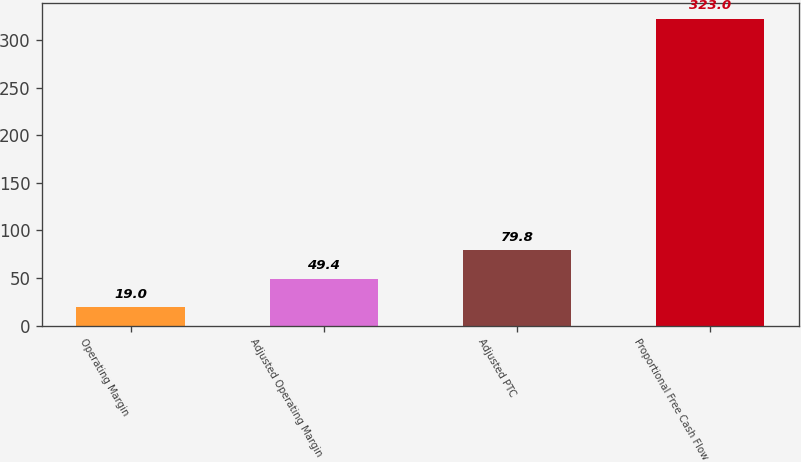Convert chart. <chart><loc_0><loc_0><loc_500><loc_500><bar_chart><fcel>Operating Margin<fcel>Adjusted Operating Margin<fcel>Adjusted PTC<fcel>Proportional Free Cash Flow<nl><fcel>19<fcel>49.4<fcel>79.8<fcel>323<nl></chart> 